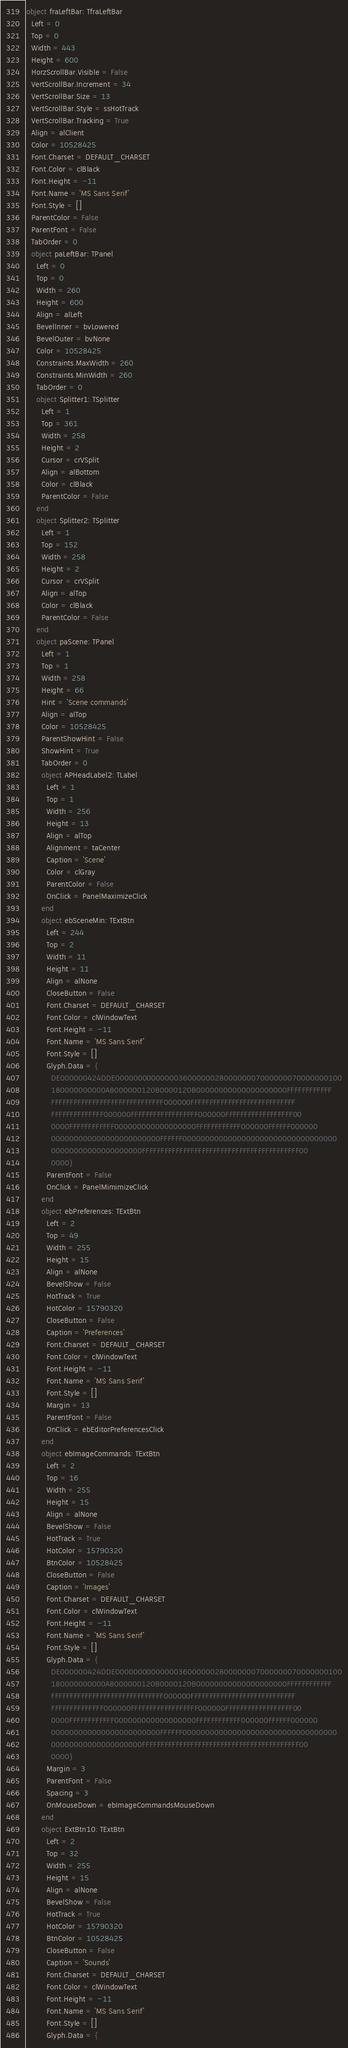<code> <loc_0><loc_0><loc_500><loc_500><_Pascal_>object fraLeftBar: TfraLeftBar
  Left = 0
  Top = 0
  Width = 443
  Height = 600
  HorzScrollBar.Visible = False
  VertScrollBar.Increment = 34
  VertScrollBar.Size = 13
  VertScrollBar.Style = ssHotTrack
  VertScrollBar.Tracking = True
  Align = alClient
  Color = 10528425
  Font.Charset = DEFAULT_CHARSET
  Font.Color = clBlack
  Font.Height = -11
  Font.Name = 'MS Sans Serif'
  Font.Style = []
  ParentColor = False
  ParentFont = False
  TabOrder = 0
  object paLeftBar: TPanel
    Left = 0
    Top = 0
    Width = 260
    Height = 600
    Align = alLeft
    BevelInner = bvLowered
    BevelOuter = bvNone
    Color = 10528425
    Constraints.MaxWidth = 260
    Constraints.MinWidth = 260
    TabOrder = 0
    object Splitter1: TSplitter
      Left = 1
      Top = 361
      Width = 258
      Height = 2
      Cursor = crVSplit
      Align = alBottom
      Color = clBlack
      ParentColor = False
    end
    object Splitter2: TSplitter
      Left = 1
      Top = 152
      Width = 258
      Height = 2
      Cursor = crVSplit
      Align = alTop
      Color = clBlack
      ParentColor = False
    end
    object paScene: TPanel
      Left = 1
      Top = 1
      Width = 258
      Height = 66
      Hint = 'Scene commands'
      Align = alTop
      Color = 10528425
      ParentShowHint = False
      ShowHint = True
      TabOrder = 0
      object APHeadLabel2: TLabel
        Left = 1
        Top = 1
        Width = 256
        Height = 13
        Align = alTop
        Alignment = taCenter
        Caption = 'Scene'
        Color = clGray
        ParentColor = False
        OnClick = PanelMaximizeClick
      end
      object ebSceneMin: TExtBtn
        Left = 244
        Top = 2
        Width = 11
        Height = 11
        Align = alNone
        CloseButton = False
        Font.Charset = DEFAULT_CHARSET
        Font.Color = clWindowText
        Font.Height = -11
        Font.Name = 'MS Sans Serif'
        Font.Style = []
        Glyph.Data = {
          DE000000424DDE00000000000000360000002800000007000000070000000100
          180000000000A8000000120B0000120B00000000000000000000FFFFFFFFFFFF
          FFFFFFFFFFFFFFFFFFFFFFFFFFFFFF000000FFFFFFFFFFFFFFFFFFFFFFFFFFFF
          FFFFFFFFFFFFFF000000FFFFFFFFFFFFFFFFFF000000FFFFFFFFFFFFFFFFFF00
          0000FFFFFFFFFFFF000000000000000000FFFFFFFFFFFF000000FFFFFF000000
          000000000000000000000000FFFFFF0000000000000000000000000000000000
          00000000000000000000FFFFFFFFFFFFFFFFFFFFFFFFFFFFFFFFFFFFFFFFFF00
          0000}
        ParentFont = False
        OnClick = PanelMimimizeClick
      end
      object ebPreferences: TExtBtn
        Left = 2
        Top = 49
        Width = 255
        Height = 15
        Align = alNone
        BevelShow = False
        HotTrack = True
        HotColor = 15790320
        CloseButton = False
        Caption = 'Preferences'
        Font.Charset = DEFAULT_CHARSET
        Font.Color = clWindowText
        Font.Height = -11
        Font.Name = 'MS Sans Serif'
        Font.Style = []
        Margin = 13
        ParentFont = False
        OnClick = ebEditorPreferencesClick
      end
      object ebImageCommands: TExtBtn
        Left = 2
        Top = 16
        Width = 255
        Height = 15
        Align = alNone
        BevelShow = False
        HotTrack = True
        HotColor = 15790320
        BtnColor = 10528425
        CloseButton = False
        Caption = 'Images'
        Font.Charset = DEFAULT_CHARSET
        Font.Color = clWindowText
        Font.Height = -11
        Font.Name = 'MS Sans Serif'
        Font.Style = []
        Glyph.Data = {
          DE000000424DDE00000000000000360000002800000007000000070000000100
          180000000000A8000000120B0000120B00000000000000000000FFFFFFFFFFFF
          FFFFFFFFFFFFFFFFFFFFFFFFFFFFFF000000FFFFFFFFFFFFFFFFFFFFFFFFFFFF
          FFFFFFFFFFFFFF000000FFFFFFFFFFFFFFFFFF000000FFFFFFFFFFFFFFFFFF00
          0000FFFFFFFFFFFF000000000000000000FFFFFFFFFFFF000000FFFFFF000000
          000000000000000000000000FFFFFF0000000000000000000000000000000000
          00000000000000000000FFFFFFFFFFFFFFFFFFFFFFFFFFFFFFFFFFFFFFFFFF00
          0000}
        Margin = 3
        ParentFont = False
        Spacing = 3
        OnMouseDown = ebImageCommandsMouseDown
      end
      object ExtBtn10: TExtBtn
        Left = 2
        Top = 32
        Width = 255
        Height = 15
        Align = alNone
        BevelShow = False
        HotTrack = True
        HotColor = 15790320
        BtnColor = 10528425
        CloseButton = False
        Caption = 'Sounds'
        Font.Charset = DEFAULT_CHARSET
        Font.Color = clWindowText
        Font.Height = -11
        Font.Name = 'MS Sans Serif'
        Font.Style = []
        Glyph.Data = {</code> 